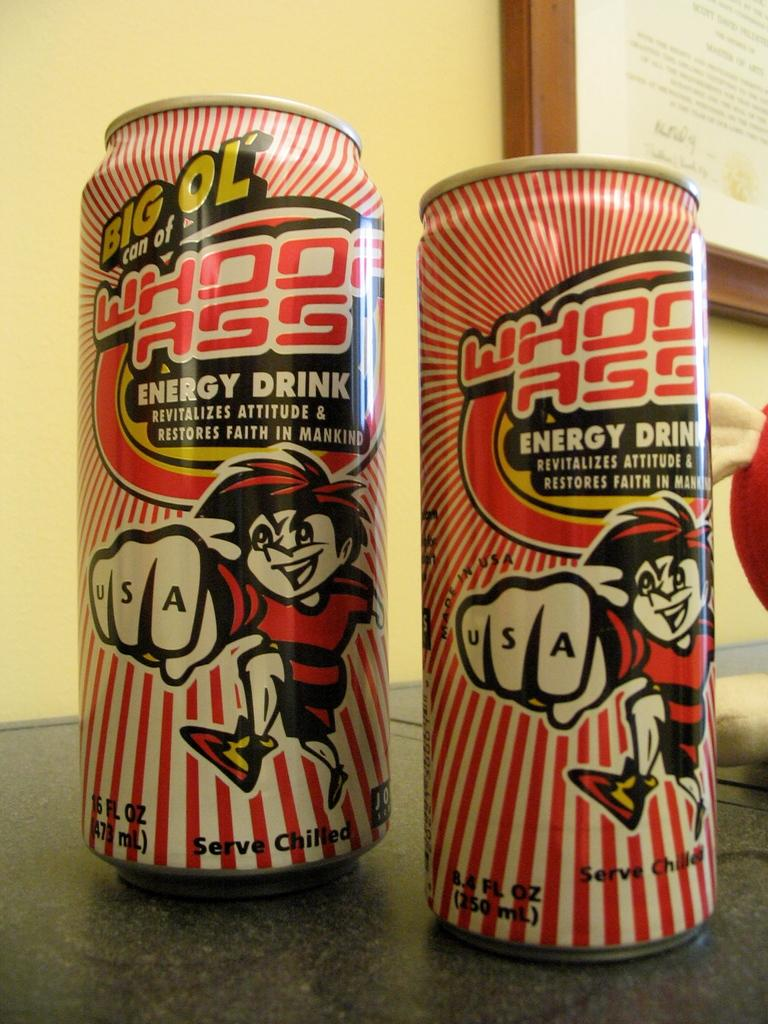<image>
Describe the image concisely. Two cans of energy drink are next to each other. 